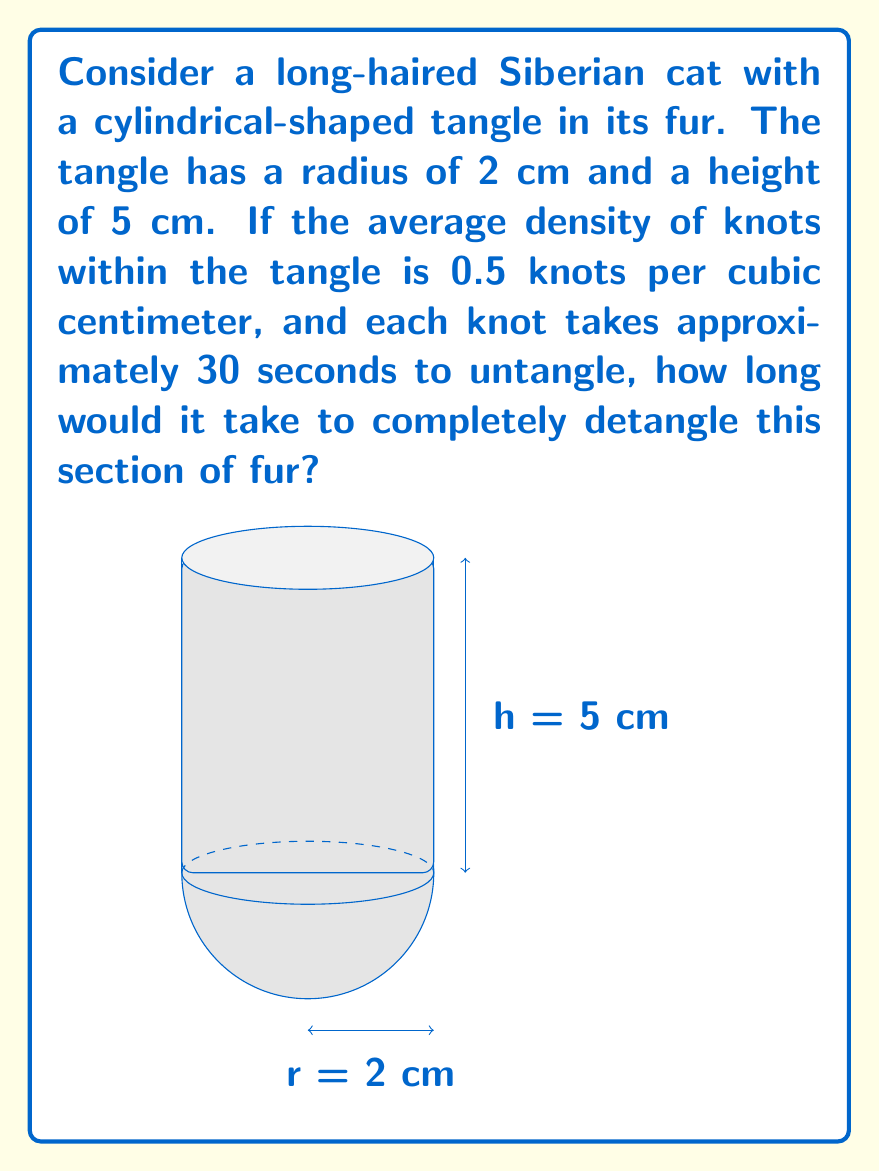Could you help me with this problem? Let's approach this problem step-by-step:

1) First, we need to calculate the volume of the cylindrical tangle. The volume of a cylinder is given by the formula:

   $$V = \pi r^2 h$$

   where $r$ is the radius and $h$ is the height.

2) Plugging in our values:

   $$V = \pi \cdot (2\text{ cm})^2 \cdot 5\text{ cm} = 20\pi\text{ cm}^3$$

3) Now, we need to determine the number of knots in this volume. We're given that the density is 0.5 knots per cubic centimeter. So:

   $$\text{Number of knots} = \text{Volume} \cdot \text{Density}$$
   $$\text{Number of knots} = 20\pi\text{ cm}^3 \cdot 0.5\text{ knots}/\text{cm}^3 = 10\pi\text{ knots}$$

4) Each knot takes 30 seconds to untangle. So the total time required is:

   $$\text{Total time} = \text{Number of knots} \cdot \text{Time per knot}$$
   $$\text{Total time} = 10\pi\text{ knots} \cdot 30\text{ seconds}/\text{knot} = 300\pi\text{ seconds}$$

5) To convert this to minutes:

   $$\text{Time in minutes} = \frac{300\pi\text{ seconds}}{60\text{ seconds}/\text{minute}} = 5\pi\text{ minutes}$$

Therefore, it would take $5\pi$ minutes, or approximately 15.71 minutes, to detangle this section of fur.
Answer: $5\pi$ minutes 